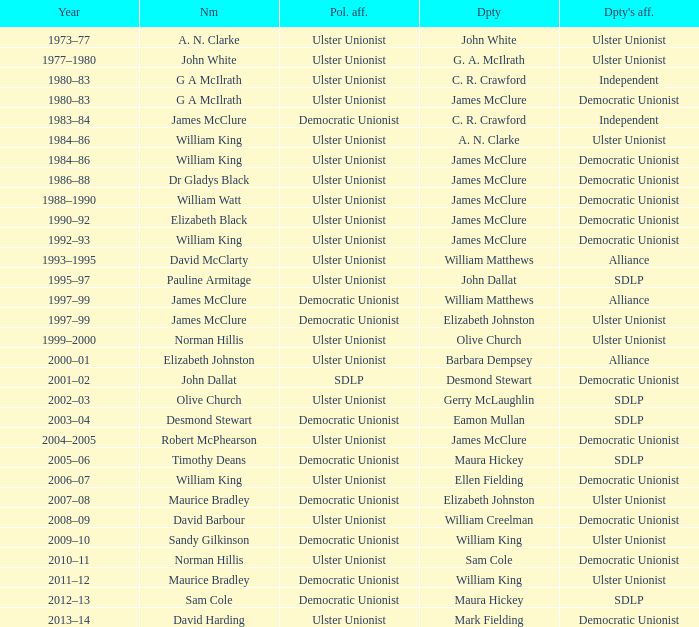What is the name of the Deputy when the Name was elizabeth black? James McClure. 